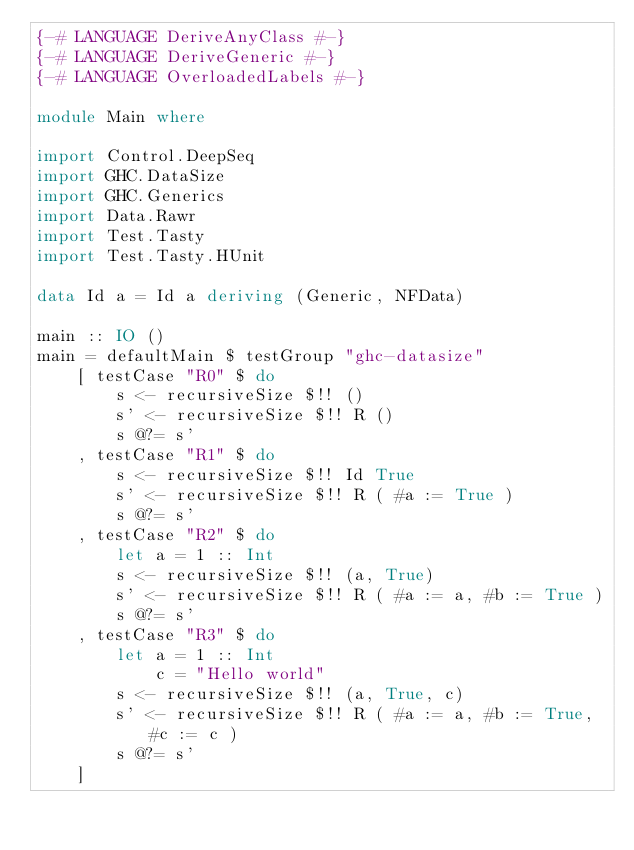<code> <loc_0><loc_0><loc_500><loc_500><_Haskell_>{-# LANGUAGE DeriveAnyClass #-}
{-# LANGUAGE DeriveGeneric #-}
{-# LANGUAGE OverloadedLabels #-}

module Main where

import Control.DeepSeq
import GHC.DataSize
import GHC.Generics
import Data.Rawr
import Test.Tasty
import Test.Tasty.HUnit

data Id a = Id a deriving (Generic, NFData)

main :: IO ()
main = defaultMain $ testGroup "ghc-datasize"
    [ testCase "R0" $ do
        s <- recursiveSize $!! ()
        s' <- recursiveSize $!! R ()
        s @?= s'
    , testCase "R1" $ do
        s <- recursiveSize $!! Id True
        s' <- recursiveSize $!! R ( #a := True )
        s @?= s'
    , testCase "R2" $ do
        let a = 1 :: Int
        s <- recursiveSize $!! (a, True)
        s' <- recursiveSize $!! R ( #a := a, #b := True )
        s @?= s'
    , testCase "R3" $ do
        let a = 1 :: Int
            c = "Hello world"
        s <- recursiveSize $!! (a, True, c)
        s' <- recursiveSize $!! R ( #a := a, #b := True, #c := c )
        s @?= s'
    ]
</code> 